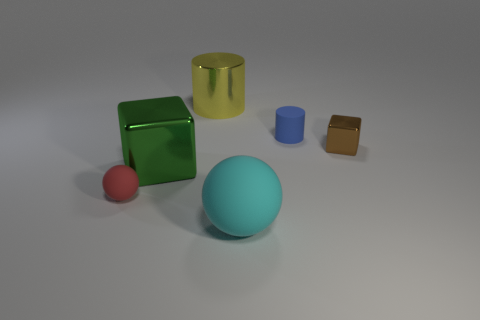Subtract 1 balls. How many balls are left? 1 Add 3 yellow objects. How many objects exist? 9 Subtract all cyan balls. How many blue cylinders are left? 1 Add 6 blue cylinders. How many blue cylinders exist? 7 Subtract 0 cyan cubes. How many objects are left? 6 Subtract all spheres. How many objects are left? 4 Subtract all blue spheres. Subtract all yellow blocks. How many spheres are left? 2 Subtract all big gray cubes. Subtract all brown metal blocks. How many objects are left? 5 Add 3 cyan matte spheres. How many cyan matte spheres are left? 4 